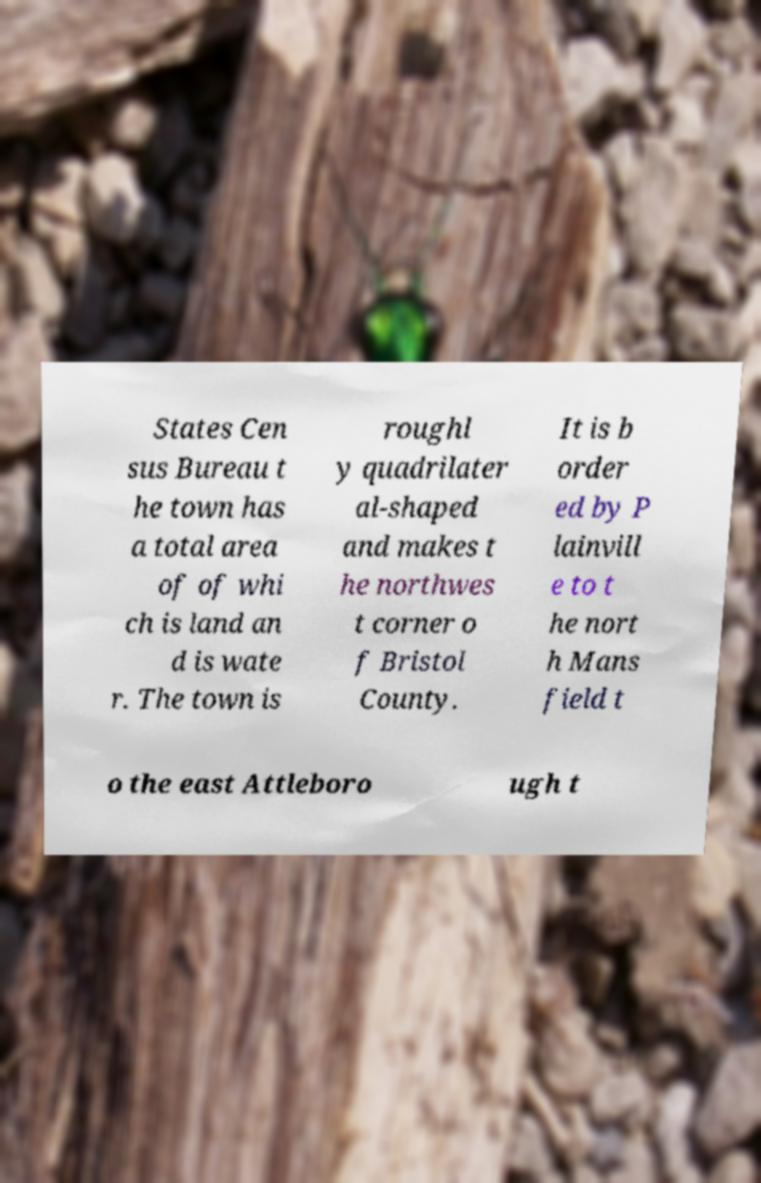Please identify and transcribe the text found in this image. States Cen sus Bureau t he town has a total area of of whi ch is land an d is wate r. The town is roughl y quadrilater al-shaped and makes t he northwes t corner o f Bristol County. It is b order ed by P lainvill e to t he nort h Mans field t o the east Attleboro ugh t 